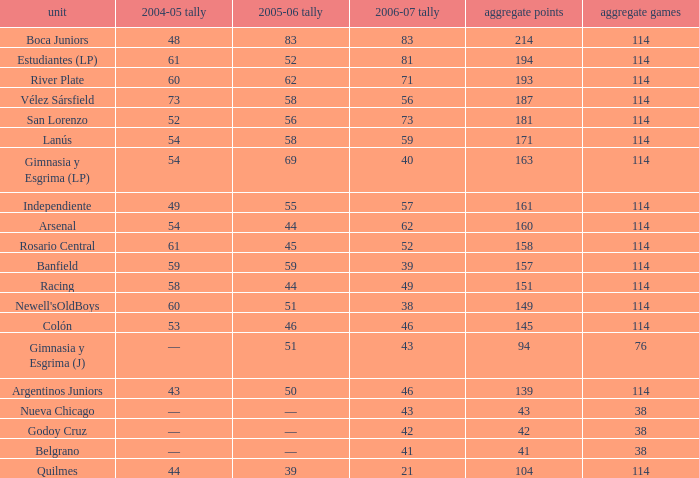What is the total number of points for a total pld less than 38? 0.0. 